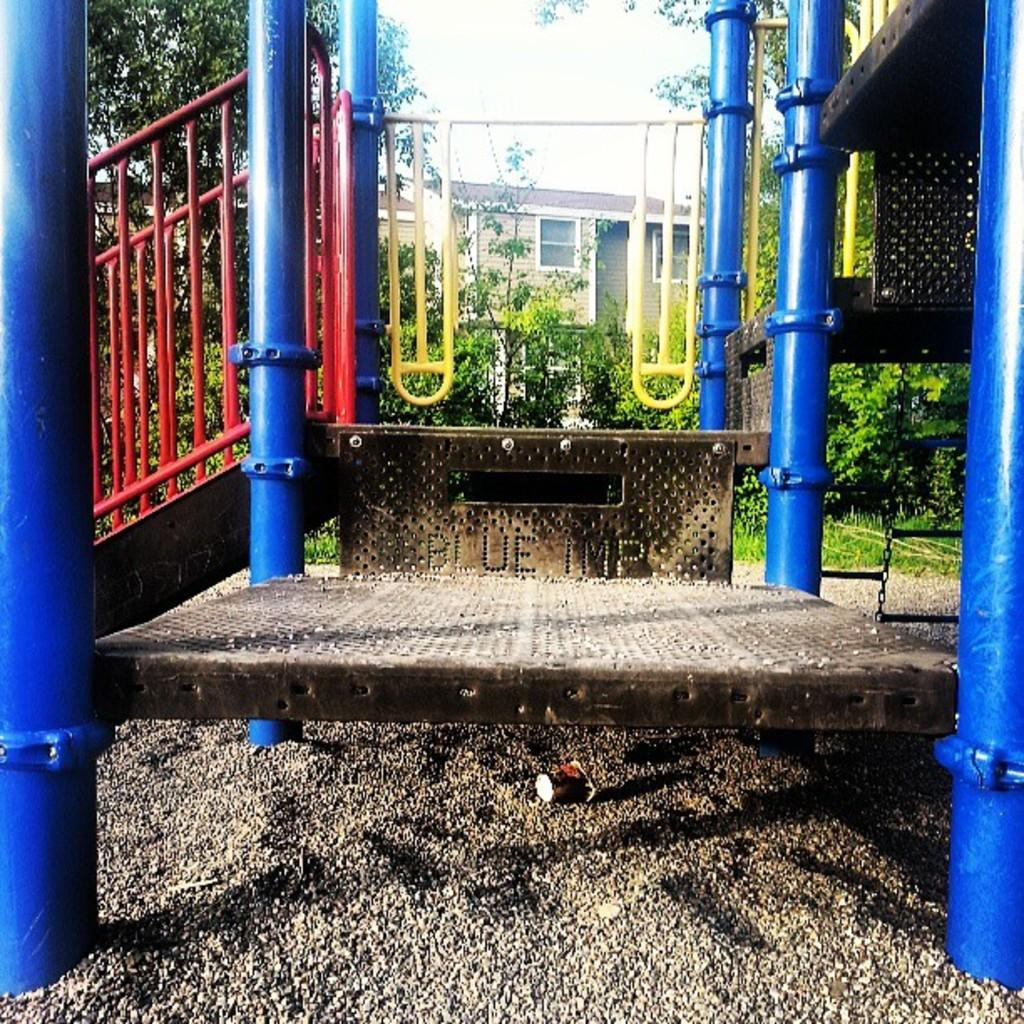What is the main object in the middle of the image? There is an iron object in the middle of the image. What color are the words in the image? The words in the image are in blue color. What can be seen in the background of the image? There are trees and a house visible in the background of the image. What type of paper is being used to write the words in the image? There is no paper visible in the image; the words are written on a different surface, possibly a metal one. 